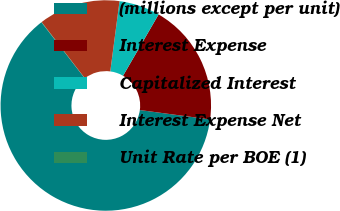<chart> <loc_0><loc_0><loc_500><loc_500><pie_chart><fcel>(millions except per unit)<fcel>Interest Expense<fcel>Capitalized Interest<fcel>Interest Expense Net<fcel>Unit Rate per BOE (1)<nl><fcel>62.39%<fcel>18.75%<fcel>6.28%<fcel>12.52%<fcel>0.05%<nl></chart> 